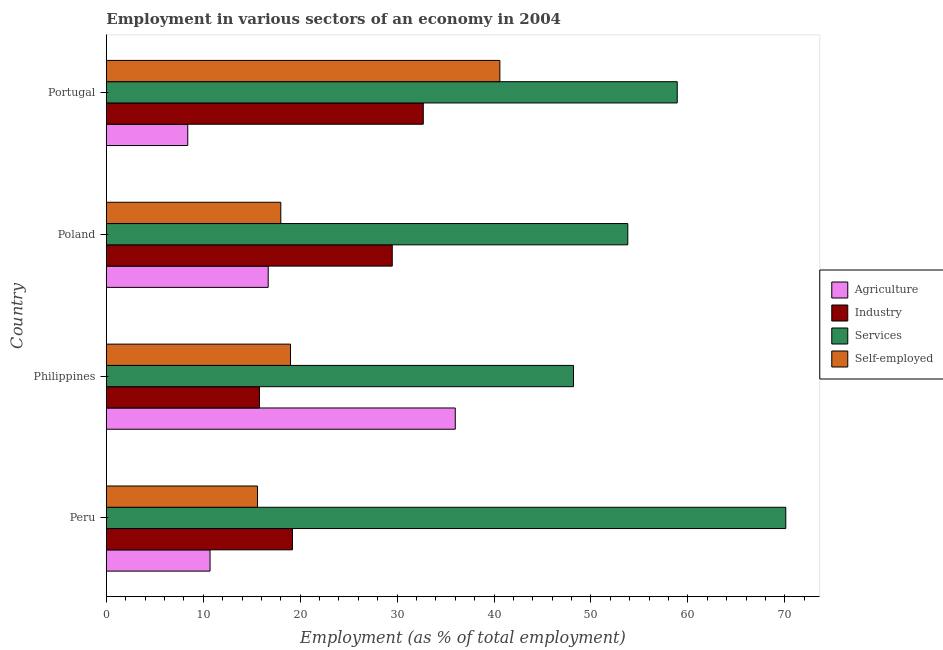How many different coloured bars are there?
Provide a succinct answer. 4. How many groups of bars are there?
Your response must be concise. 4. Are the number of bars per tick equal to the number of legend labels?
Make the answer very short. Yes. How many bars are there on the 4th tick from the top?
Provide a short and direct response. 4. How many bars are there on the 2nd tick from the bottom?
Give a very brief answer. 4. In how many cases, is the number of bars for a given country not equal to the number of legend labels?
Make the answer very short. 0. What is the percentage of workers in industry in Poland?
Provide a short and direct response. 29.5. Across all countries, what is the maximum percentage of self employed workers?
Your response must be concise. 40.6. Across all countries, what is the minimum percentage of workers in industry?
Your response must be concise. 15.8. In which country was the percentage of workers in agriculture maximum?
Offer a terse response. Philippines. What is the total percentage of workers in industry in the graph?
Offer a terse response. 97.2. What is the difference between the percentage of self employed workers in Philippines and that in Portugal?
Your answer should be compact. -21.6. What is the difference between the percentage of workers in industry in Peru and the percentage of self employed workers in Poland?
Provide a succinct answer. 1.2. What is the average percentage of workers in services per country?
Your response must be concise. 57.75. In how many countries, is the percentage of workers in services greater than 16 %?
Your answer should be compact. 4. What is the ratio of the percentage of workers in services in Philippines to that in Poland?
Provide a short and direct response. 0.9. Is the percentage of workers in industry in Peru less than that in Portugal?
Keep it short and to the point. Yes. Is the difference between the percentage of self employed workers in Peru and Portugal greater than the difference between the percentage of workers in industry in Peru and Portugal?
Provide a succinct answer. No. What is the difference between the highest and the second highest percentage of workers in agriculture?
Ensure brevity in your answer.  19.3. What is the difference between the highest and the lowest percentage of workers in industry?
Your answer should be compact. 16.9. In how many countries, is the percentage of self employed workers greater than the average percentage of self employed workers taken over all countries?
Give a very brief answer. 1. What does the 4th bar from the top in Philippines represents?
Provide a short and direct response. Agriculture. What does the 4th bar from the bottom in Peru represents?
Your answer should be very brief. Self-employed. How many bars are there?
Your answer should be compact. 16. Are all the bars in the graph horizontal?
Offer a terse response. Yes. How many countries are there in the graph?
Give a very brief answer. 4. Does the graph contain any zero values?
Your answer should be very brief. No. Where does the legend appear in the graph?
Your response must be concise. Center right. What is the title of the graph?
Offer a terse response. Employment in various sectors of an economy in 2004. Does "Pre-primary schools" appear as one of the legend labels in the graph?
Give a very brief answer. No. What is the label or title of the X-axis?
Give a very brief answer. Employment (as % of total employment). What is the Employment (as % of total employment) in Agriculture in Peru?
Your response must be concise. 10.7. What is the Employment (as % of total employment) of Industry in Peru?
Make the answer very short. 19.2. What is the Employment (as % of total employment) in Services in Peru?
Offer a very short reply. 70.1. What is the Employment (as % of total employment) in Self-employed in Peru?
Provide a short and direct response. 15.6. What is the Employment (as % of total employment) of Agriculture in Philippines?
Make the answer very short. 36. What is the Employment (as % of total employment) in Industry in Philippines?
Offer a terse response. 15.8. What is the Employment (as % of total employment) of Services in Philippines?
Make the answer very short. 48.2. What is the Employment (as % of total employment) of Agriculture in Poland?
Provide a short and direct response. 16.7. What is the Employment (as % of total employment) in Industry in Poland?
Make the answer very short. 29.5. What is the Employment (as % of total employment) in Services in Poland?
Give a very brief answer. 53.8. What is the Employment (as % of total employment) of Self-employed in Poland?
Provide a short and direct response. 18. What is the Employment (as % of total employment) of Agriculture in Portugal?
Your answer should be very brief. 8.4. What is the Employment (as % of total employment) in Industry in Portugal?
Offer a very short reply. 32.7. What is the Employment (as % of total employment) in Services in Portugal?
Your answer should be very brief. 58.9. What is the Employment (as % of total employment) of Self-employed in Portugal?
Offer a terse response. 40.6. Across all countries, what is the maximum Employment (as % of total employment) in Industry?
Make the answer very short. 32.7. Across all countries, what is the maximum Employment (as % of total employment) of Services?
Keep it short and to the point. 70.1. Across all countries, what is the maximum Employment (as % of total employment) in Self-employed?
Your answer should be very brief. 40.6. Across all countries, what is the minimum Employment (as % of total employment) in Agriculture?
Ensure brevity in your answer.  8.4. Across all countries, what is the minimum Employment (as % of total employment) in Industry?
Provide a short and direct response. 15.8. Across all countries, what is the minimum Employment (as % of total employment) of Services?
Your answer should be very brief. 48.2. Across all countries, what is the minimum Employment (as % of total employment) in Self-employed?
Offer a terse response. 15.6. What is the total Employment (as % of total employment) of Agriculture in the graph?
Your answer should be compact. 71.8. What is the total Employment (as % of total employment) of Industry in the graph?
Make the answer very short. 97.2. What is the total Employment (as % of total employment) in Services in the graph?
Provide a succinct answer. 231. What is the total Employment (as % of total employment) of Self-employed in the graph?
Give a very brief answer. 93.2. What is the difference between the Employment (as % of total employment) of Agriculture in Peru and that in Philippines?
Ensure brevity in your answer.  -25.3. What is the difference between the Employment (as % of total employment) of Services in Peru and that in Philippines?
Your answer should be compact. 21.9. What is the difference between the Employment (as % of total employment) of Industry in Peru and that in Poland?
Keep it short and to the point. -10.3. What is the difference between the Employment (as % of total employment) of Services in Peru and that in Poland?
Your response must be concise. 16.3. What is the difference between the Employment (as % of total employment) in Agriculture in Philippines and that in Poland?
Ensure brevity in your answer.  19.3. What is the difference between the Employment (as % of total employment) of Industry in Philippines and that in Poland?
Provide a short and direct response. -13.7. What is the difference between the Employment (as % of total employment) of Services in Philippines and that in Poland?
Provide a short and direct response. -5.6. What is the difference between the Employment (as % of total employment) in Self-employed in Philippines and that in Poland?
Give a very brief answer. 1. What is the difference between the Employment (as % of total employment) in Agriculture in Philippines and that in Portugal?
Provide a short and direct response. 27.6. What is the difference between the Employment (as % of total employment) of Industry in Philippines and that in Portugal?
Make the answer very short. -16.9. What is the difference between the Employment (as % of total employment) in Self-employed in Philippines and that in Portugal?
Ensure brevity in your answer.  -21.6. What is the difference between the Employment (as % of total employment) in Self-employed in Poland and that in Portugal?
Your answer should be very brief. -22.6. What is the difference between the Employment (as % of total employment) of Agriculture in Peru and the Employment (as % of total employment) of Industry in Philippines?
Ensure brevity in your answer.  -5.1. What is the difference between the Employment (as % of total employment) of Agriculture in Peru and the Employment (as % of total employment) of Services in Philippines?
Your response must be concise. -37.5. What is the difference between the Employment (as % of total employment) of Industry in Peru and the Employment (as % of total employment) of Services in Philippines?
Offer a very short reply. -29. What is the difference between the Employment (as % of total employment) in Industry in Peru and the Employment (as % of total employment) in Self-employed in Philippines?
Your response must be concise. 0.2. What is the difference between the Employment (as % of total employment) in Services in Peru and the Employment (as % of total employment) in Self-employed in Philippines?
Your response must be concise. 51.1. What is the difference between the Employment (as % of total employment) in Agriculture in Peru and the Employment (as % of total employment) in Industry in Poland?
Keep it short and to the point. -18.8. What is the difference between the Employment (as % of total employment) in Agriculture in Peru and the Employment (as % of total employment) in Services in Poland?
Give a very brief answer. -43.1. What is the difference between the Employment (as % of total employment) in Industry in Peru and the Employment (as % of total employment) in Services in Poland?
Provide a succinct answer. -34.6. What is the difference between the Employment (as % of total employment) in Services in Peru and the Employment (as % of total employment) in Self-employed in Poland?
Offer a very short reply. 52.1. What is the difference between the Employment (as % of total employment) in Agriculture in Peru and the Employment (as % of total employment) in Industry in Portugal?
Give a very brief answer. -22. What is the difference between the Employment (as % of total employment) of Agriculture in Peru and the Employment (as % of total employment) of Services in Portugal?
Make the answer very short. -48.2. What is the difference between the Employment (as % of total employment) in Agriculture in Peru and the Employment (as % of total employment) in Self-employed in Portugal?
Make the answer very short. -29.9. What is the difference between the Employment (as % of total employment) in Industry in Peru and the Employment (as % of total employment) in Services in Portugal?
Provide a succinct answer. -39.7. What is the difference between the Employment (as % of total employment) of Industry in Peru and the Employment (as % of total employment) of Self-employed in Portugal?
Provide a succinct answer. -21.4. What is the difference between the Employment (as % of total employment) in Services in Peru and the Employment (as % of total employment) in Self-employed in Portugal?
Give a very brief answer. 29.5. What is the difference between the Employment (as % of total employment) in Agriculture in Philippines and the Employment (as % of total employment) in Industry in Poland?
Keep it short and to the point. 6.5. What is the difference between the Employment (as % of total employment) of Agriculture in Philippines and the Employment (as % of total employment) of Services in Poland?
Keep it short and to the point. -17.8. What is the difference between the Employment (as % of total employment) of Industry in Philippines and the Employment (as % of total employment) of Services in Poland?
Provide a short and direct response. -38. What is the difference between the Employment (as % of total employment) in Services in Philippines and the Employment (as % of total employment) in Self-employed in Poland?
Your response must be concise. 30.2. What is the difference between the Employment (as % of total employment) in Agriculture in Philippines and the Employment (as % of total employment) in Industry in Portugal?
Make the answer very short. 3.3. What is the difference between the Employment (as % of total employment) of Agriculture in Philippines and the Employment (as % of total employment) of Services in Portugal?
Provide a short and direct response. -22.9. What is the difference between the Employment (as % of total employment) of Industry in Philippines and the Employment (as % of total employment) of Services in Portugal?
Make the answer very short. -43.1. What is the difference between the Employment (as % of total employment) of Industry in Philippines and the Employment (as % of total employment) of Self-employed in Portugal?
Give a very brief answer. -24.8. What is the difference between the Employment (as % of total employment) in Agriculture in Poland and the Employment (as % of total employment) in Services in Portugal?
Offer a terse response. -42.2. What is the difference between the Employment (as % of total employment) of Agriculture in Poland and the Employment (as % of total employment) of Self-employed in Portugal?
Make the answer very short. -23.9. What is the difference between the Employment (as % of total employment) of Industry in Poland and the Employment (as % of total employment) of Services in Portugal?
Keep it short and to the point. -29.4. What is the difference between the Employment (as % of total employment) in Industry in Poland and the Employment (as % of total employment) in Self-employed in Portugal?
Offer a terse response. -11.1. What is the average Employment (as % of total employment) of Agriculture per country?
Provide a succinct answer. 17.95. What is the average Employment (as % of total employment) in Industry per country?
Give a very brief answer. 24.3. What is the average Employment (as % of total employment) in Services per country?
Keep it short and to the point. 57.75. What is the average Employment (as % of total employment) of Self-employed per country?
Your answer should be compact. 23.3. What is the difference between the Employment (as % of total employment) in Agriculture and Employment (as % of total employment) in Industry in Peru?
Keep it short and to the point. -8.5. What is the difference between the Employment (as % of total employment) in Agriculture and Employment (as % of total employment) in Services in Peru?
Ensure brevity in your answer.  -59.4. What is the difference between the Employment (as % of total employment) in Agriculture and Employment (as % of total employment) in Self-employed in Peru?
Offer a very short reply. -4.9. What is the difference between the Employment (as % of total employment) of Industry and Employment (as % of total employment) of Services in Peru?
Provide a short and direct response. -50.9. What is the difference between the Employment (as % of total employment) in Industry and Employment (as % of total employment) in Self-employed in Peru?
Give a very brief answer. 3.6. What is the difference between the Employment (as % of total employment) of Services and Employment (as % of total employment) of Self-employed in Peru?
Make the answer very short. 54.5. What is the difference between the Employment (as % of total employment) in Agriculture and Employment (as % of total employment) in Industry in Philippines?
Ensure brevity in your answer.  20.2. What is the difference between the Employment (as % of total employment) of Industry and Employment (as % of total employment) of Services in Philippines?
Your answer should be compact. -32.4. What is the difference between the Employment (as % of total employment) in Services and Employment (as % of total employment) in Self-employed in Philippines?
Ensure brevity in your answer.  29.2. What is the difference between the Employment (as % of total employment) in Agriculture and Employment (as % of total employment) in Industry in Poland?
Provide a short and direct response. -12.8. What is the difference between the Employment (as % of total employment) of Agriculture and Employment (as % of total employment) of Services in Poland?
Make the answer very short. -37.1. What is the difference between the Employment (as % of total employment) of Agriculture and Employment (as % of total employment) of Self-employed in Poland?
Offer a very short reply. -1.3. What is the difference between the Employment (as % of total employment) in Industry and Employment (as % of total employment) in Services in Poland?
Provide a short and direct response. -24.3. What is the difference between the Employment (as % of total employment) of Services and Employment (as % of total employment) of Self-employed in Poland?
Offer a very short reply. 35.8. What is the difference between the Employment (as % of total employment) of Agriculture and Employment (as % of total employment) of Industry in Portugal?
Your response must be concise. -24.3. What is the difference between the Employment (as % of total employment) in Agriculture and Employment (as % of total employment) in Services in Portugal?
Make the answer very short. -50.5. What is the difference between the Employment (as % of total employment) of Agriculture and Employment (as % of total employment) of Self-employed in Portugal?
Ensure brevity in your answer.  -32.2. What is the difference between the Employment (as % of total employment) in Industry and Employment (as % of total employment) in Services in Portugal?
Keep it short and to the point. -26.2. What is the difference between the Employment (as % of total employment) of Industry and Employment (as % of total employment) of Self-employed in Portugal?
Make the answer very short. -7.9. What is the difference between the Employment (as % of total employment) in Services and Employment (as % of total employment) in Self-employed in Portugal?
Give a very brief answer. 18.3. What is the ratio of the Employment (as % of total employment) of Agriculture in Peru to that in Philippines?
Offer a very short reply. 0.3. What is the ratio of the Employment (as % of total employment) in Industry in Peru to that in Philippines?
Give a very brief answer. 1.22. What is the ratio of the Employment (as % of total employment) of Services in Peru to that in Philippines?
Keep it short and to the point. 1.45. What is the ratio of the Employment (as % of total employment) of Self-employed in Peru to that in Philippines?
Your response must be concise. 0.82. What is the ratio of the Employment (as % of total employment) of Agriculture in Peru to that in Poland?
Make the answer very short. 0.64. What is the ratio of the Employment (as % of total employment) in Industry in Peru to that in Poland?
Your response must be concise. 0.65. What is the ratio of the Employment (as % of total employment) in Services in Peru to that in Poland?
Make the answer very short. 1.3. What is the ratio of the Employment (as % of total employment) in Self-employed in Peru to that in Poland?
Your answer should be very brief. 0.87. What is the ratio of the Employment (as % of total employment) in Agriculture in Peru to that in Portugal?
Your answer should be compact. 1.27. What is the ratio of the Employment (as % of total employment) in Industry in Peru to that in Portugal?
Your answer should be very brief. 0.59. What is the ratio of the Employment (as % of total employment) of Services in Peru to that in Portugal?
Ensure brevity in your answer.  1.19. What is the ratio of the Employment (as % of total employment) of Self-employed in Peru to that in Portugal?
Offer a terse response. 0.38. What is the ratio of the Employment (as % of total employment) in Agriculture in Philippines to that in Poland?
Your answer should be compact. 2.16. What is the ratio of the Employment (as % of total employment) of Industry in Philippines to that in Poland?
Provide a succinct answer. 0.54. What is the ratio of the Employment (as % of total employment) in Services in Philippines to that in Poland?
Your answer should be compact. 0.9. What is the ratio of the Employment (as % of total employment) of Self-employed in Philippines to that in Poland?
Ensure brevity in your answer.  1.06. What is the ratio of the Employment (as % of total employment) of Agriculture in Philippines to that in Portugal?
Provide a short and direct response. 4.29. What is the ratio of the Employment (as % of total employment) of Industry in Philippines to that in Portugal?
Provide a short and direct response. 0.48. What is the ratio of the Employment (as % of total employment) of Services in Philippines to that in Portugal?
Ensure brevity in your answer.  0.82. What is the ratio of the Employment (as % of total employment) in Self-employed in Philippines to that in Portugal?
Provide a short and direct response. 0.47. What is the ratio of the Employment (as % of total employment) in Agriculture in Poland to that in Portugal?
Your response must be concise. 1.99. What is the ratio of the Employment (as % of total employment) of Industry in Poland to that in Portugal?
Keep it short and to the point. 0.9. What is the ratio of the Employment (as % of total employment) in Services in Poland to that in Portugal?
Provide a short and direct response. 0.91. What is the ratio of the Employment (as % of total employment) in Self-employed in Poland to that in Portugal?
Keep it short and to the point. 0.44. What is the difference between the highest and the second highest Employment (as % of total employment) of Agriculture?
Make the answer very short. 19.3. What is the difference between the highest and the second highest Employment (as % of total employment) in Services?
Provide a succinct answer. 11.2. What is the difference between the highest and the second highest Employment (as % of total employment) in Self-employed?
Provide a succinct answer. 21.6. What is the difference between the highest and the lowest Employment (as % of total employment) of Agriculture?
Keep it short and to the point. 27.6. What is the difference between the highest and the lowest Employment (as % of total employment) in Industry?
Your answer should be compact. 16.9. What is the difference between the highest and the lowest Employment (as % of total employment) in Services?
Your answer should be compact. 21.9. 